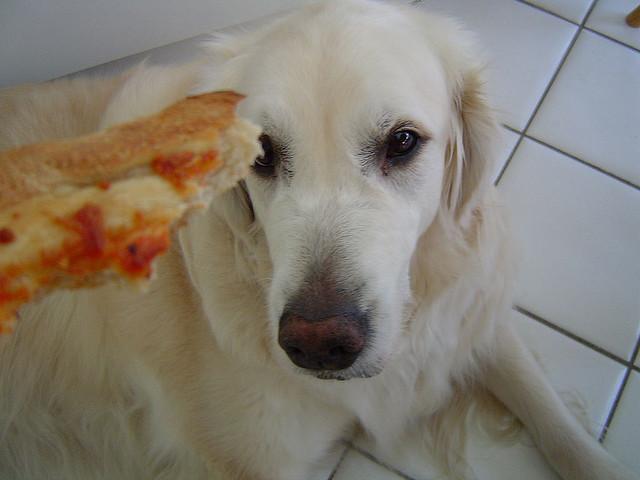How many of the people are eating?
Give a very brief answer. 0. 